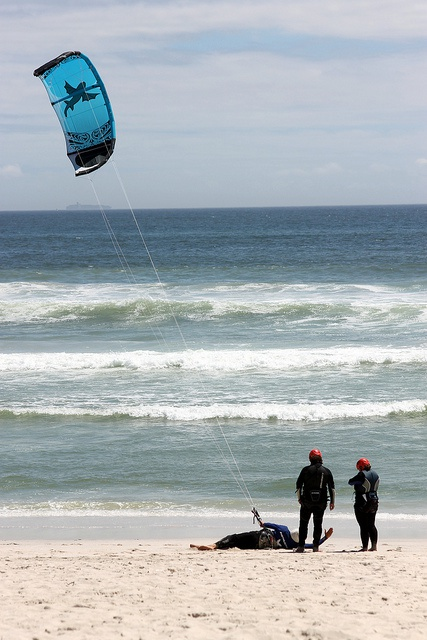Describe the objects in this image and their specific colors. I can see kite in darkgray, lightblue, black, teal, and blue tones, people in darkgray, black, gray, and maroon tones, people in darkgray, black, gray, and maroon tones, and people in darkgray, black, gray, maroon, and navy tones in this image. 